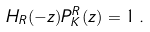<formula> <loc_0><loc_0><loc_500><loc_500>H _ { R } ( - z ) P _ { K } ^ { R } ( z ) = 1 \, .</formula> 